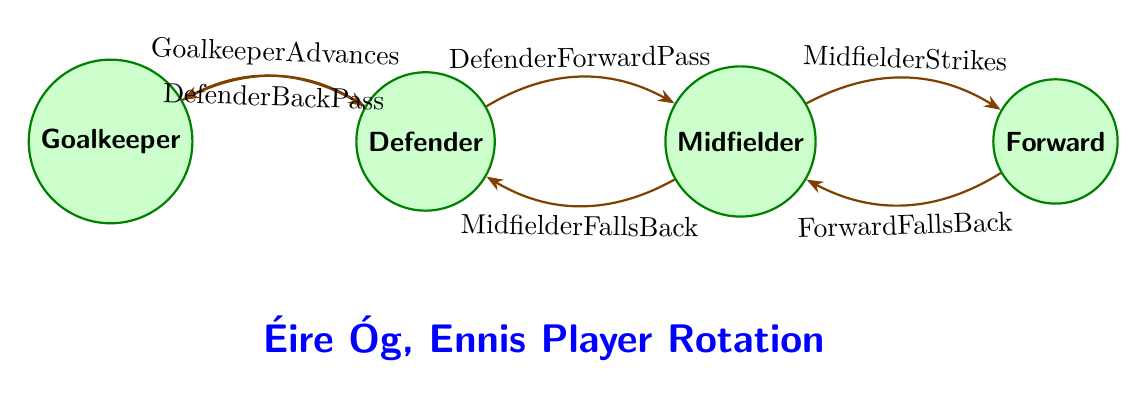What is the starting position of the player? The starting position in this finite state machine is the "Goalkeeper." This is the first state listed in the diagram and indicates the initial role a player can have.
Answer: Goalkeeper How many player positions are represented in the diagram? There are four distinct player positions represented: Goalkeeper, Defender, Midfielder, and Forward. This can be counted directly from the states listed in the diagram.
Answer: 4 Which position can the Defender transition to with a specific condition? The Defender can transition to the Midfielder position under the condition "DefenderForwardPass." This is explicitly stated in one of the transitions coming from the Defender state.
Answer: Midfielder What happens when the Midfielder strikes? When the Midfielder strikes, they transition to the Forward position. This is the result of the transition labeled "MidfielderStrikes" from the Midfielder state.
Answer: Forward If the Forward falls back, which position do they return to? If the Forward falls back, they return to the Midfielder position. This is indicated by the transition labeled "ForwardFallsBack" that connects the Forward state back to the Midfielder state.
Answer: Midfielder What is the condition for a Defender to revert to being the Goalkeeper? The condition for the Defender to revert to being the Goalkeeper is "DefenderBackPass." This transition shows that the Defender can go back to the previous position of Goalkeeper under this specific condition.
Answer: DefenderBackPass Which position is a transition option for a Midfielder when they need to fall back? The transition option for a Midfielder when they need to fall back is to return to the Defender position. This is represented in the diagram by the transition labeled "MidfielderFallsBack."
Answer: Defender What occurs if the player is in the Goalkeeper position and they advance? If the player is in the Goalkeeper position and they advance, they transition to the Defender position. This transition is specified by the condition "GoalkeeperAdvances" leading to the Defender state.
Answer: Defender 